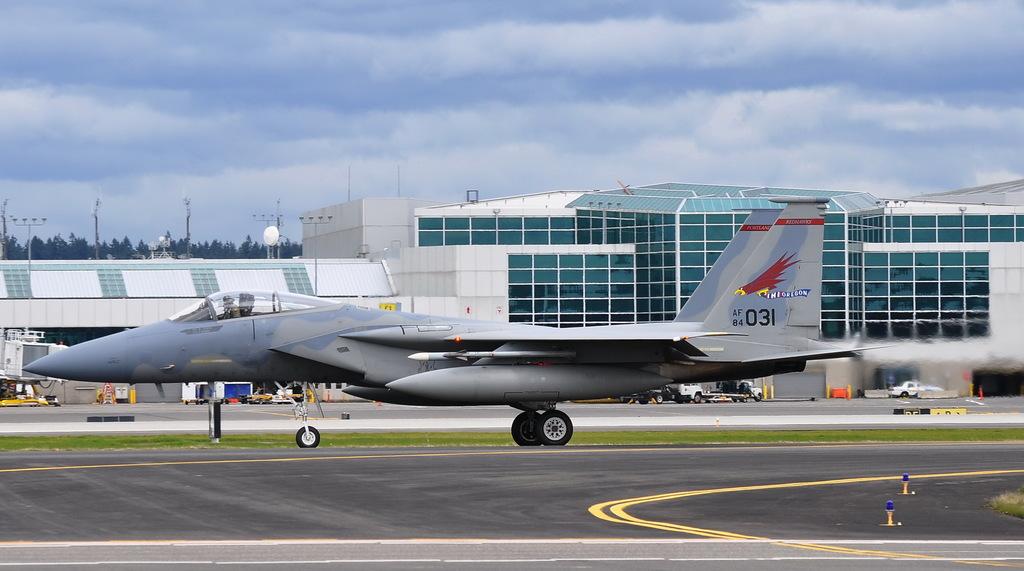What is the number on the airplane?
Ensure brevity in your answer.  031. What is the name is the plane?
Ensure brevity in your answer.  Unanswerable. 